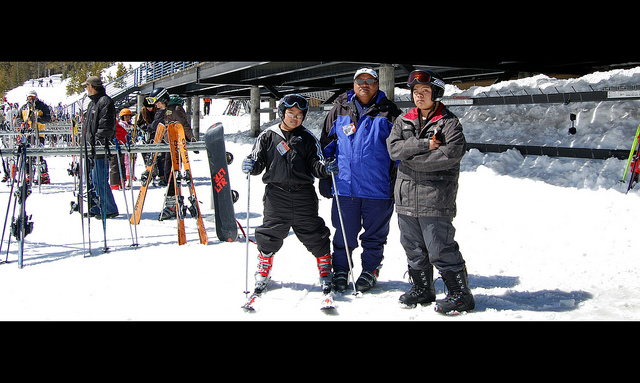What does the environment suggest about the location? The environment, with abundant snow underfoot and a clear, sunny sky, suggests that this is a popular ski resort. The presence of other skis and equipment in the background further indicates that this location is well-equipped for winter sports. The setup appears to be organized, likely part of a ski rental or school area. 